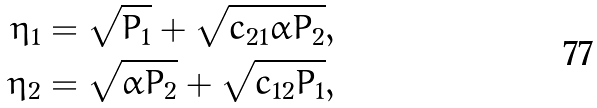<formula> <loc_0><loc_0><loc_500><loc_500>\eta _ { 1 } & = \sqrt { P _ { 1 } } + \sqrt { c _ { 2 1 } \bar { \alpha } P _ { 2 } } , \\ \eta _ { 2 } & = \sqrt { \bar { \alpha } P _ { 2 } } + \sqrt { c _ { 1 2 } P _ { 1 } } ,</formula> 